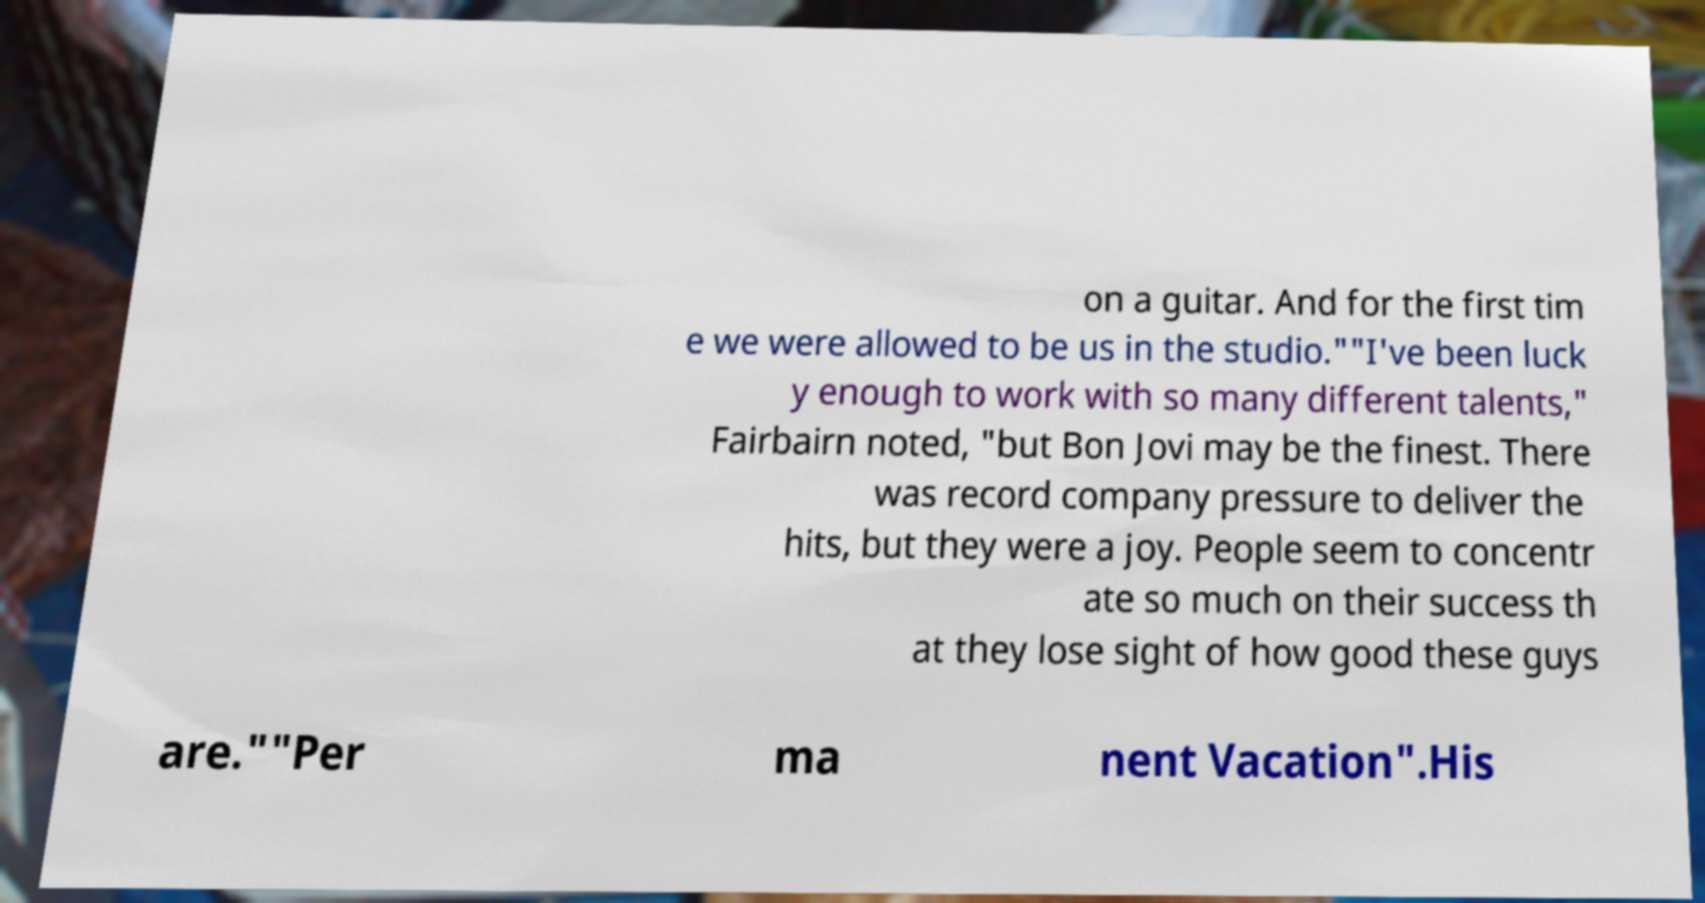There's text embedded in this image that I need extracted. Can you transcribe it verbatim? on a guitar. And for the first tim e we were allowed to be us in the studio.""I've been luck y enough to work with so many different talents," Fairbairn noted, "but Bon Jovi may be the finest. There was record company pressure to deliver the hits, but they were a joy. People seem to concentr ate so much on their success th at they lose sight of how good these guys are.""Per ma nent Vacation".His 